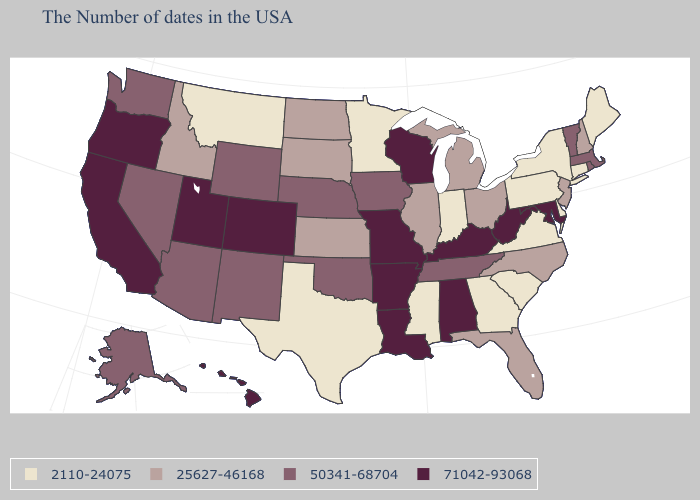Name the states that have a value in the range 2110-24075?
Keep it brief. Maine, Connecticut, New York, Delaware, Pennsylvania, Virginia, South Carolina, Georgia, Indiana, Mississippi, Minnesota, Texas, Montana. Which states have the lowest value in the Northeast?
Write a very short answer. Maine, Connecticut, New York, Pennsylvania. Which states have the highest value in the USA?
Give a very brief answer. Maryland, West Virginia, Kentucky, Alabama, Wisconsin, Louisiana, Missouri, Arkansas, Colorado, Utah, California, Oregon, Hawaii. What is the value of New Jersey?
Write a very short answer. 25627-46168. Does Alabama have the lowest value in the USA?
Concise answer only. No. Which states have the lowest value in the USA?
Keep it brief. Maine, Connecticut, New York, Delaware, Pennsylvania, Virginia, South Carolina, Georgia, Indiana, Mississippi, Minnesota, Texas, Montana. Does Nebraska have the highest value in the USA?
Keep it brief. No. Name the states that have a value in the range 71042-93068?
Concise answer only. Maryland, West Virginia, Kentucky, Alabama, Wisconsin, Louisiana, Missouri, Arkansas, Colorado, Utah, California, Oregon, Hawaii. Name the states that have a value in the range 71042-93068?
Short answer required. Maryland, West Virginia, Kentucky, Alabama, Wisconsin, Louisiana, Missouri, Arkansas, Colorado, Utah, California, Oregon, Hawaii. Does Virginia have the highest value in the South?
Short answer required. No. Does Iowa have the same value as Oklahoma?
Short answer required. Yes. Name the states that have a value in the range 2110-24075?
Concise answer only. Maine, Connecticut, New York, Delaware, Pennsylvania, Virginia, South Carolina, Georgia, Indiana, Mississippi, Minnesota, Texas, Montana. What is the lowest value in the USA?
Answer briefly. 2110-24075. Among the states that border Nebraska , which have the highest value?
Keep it brief. Missouri, Colorado. What is the highest value in states that border Kansas?
Write a very short answer. 71042-93068. 